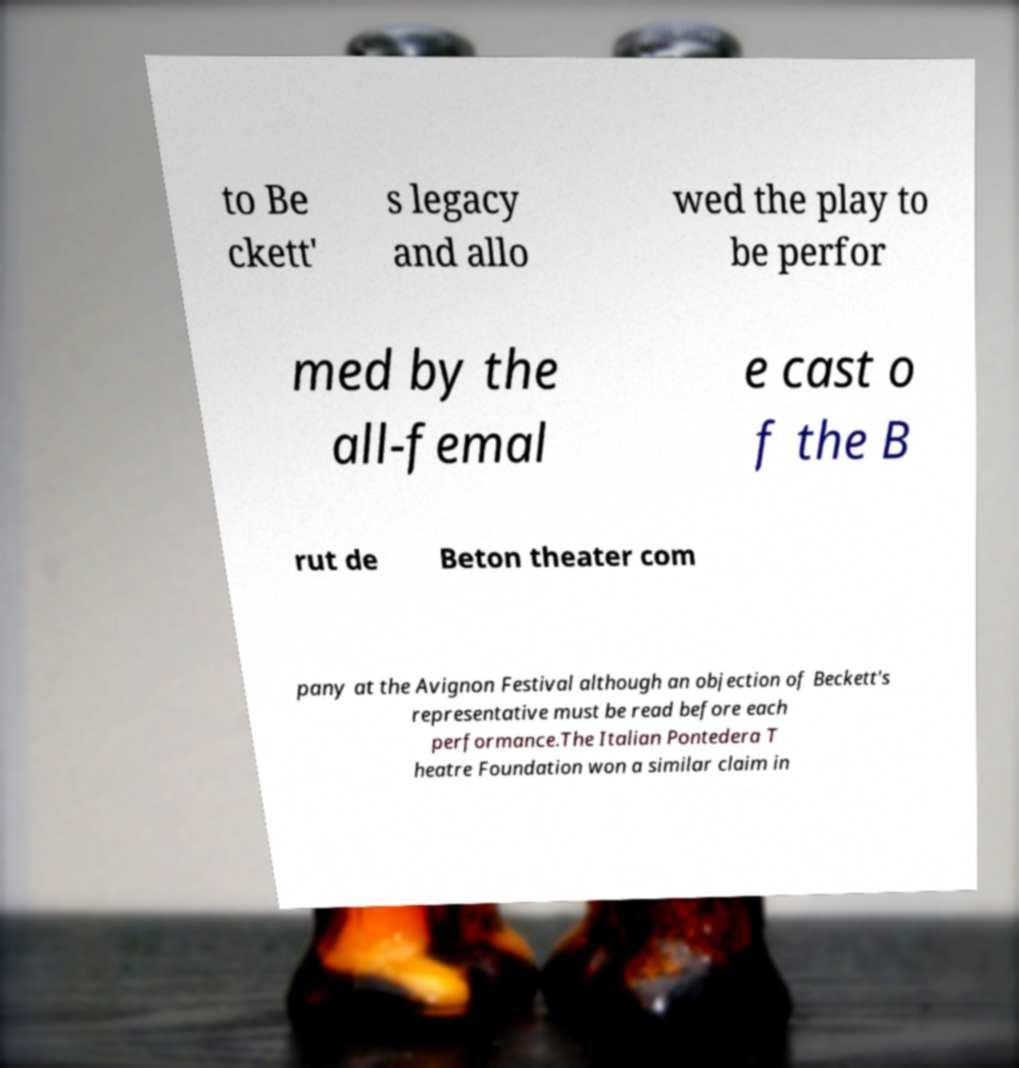Can you read and provide the text displayed in the image?This photo seems to have some interesting text. Can you extract and type it out for me? to Be ckett' s legacy and allo wed the play to be perfor med by the all-femal e cast o f the B rut de Beton theater com pany at the Avignon Festival although an objection of Beckett's representative must be read before each performance.The Italian Pontedera T heatre Foundation won a similar claim in 